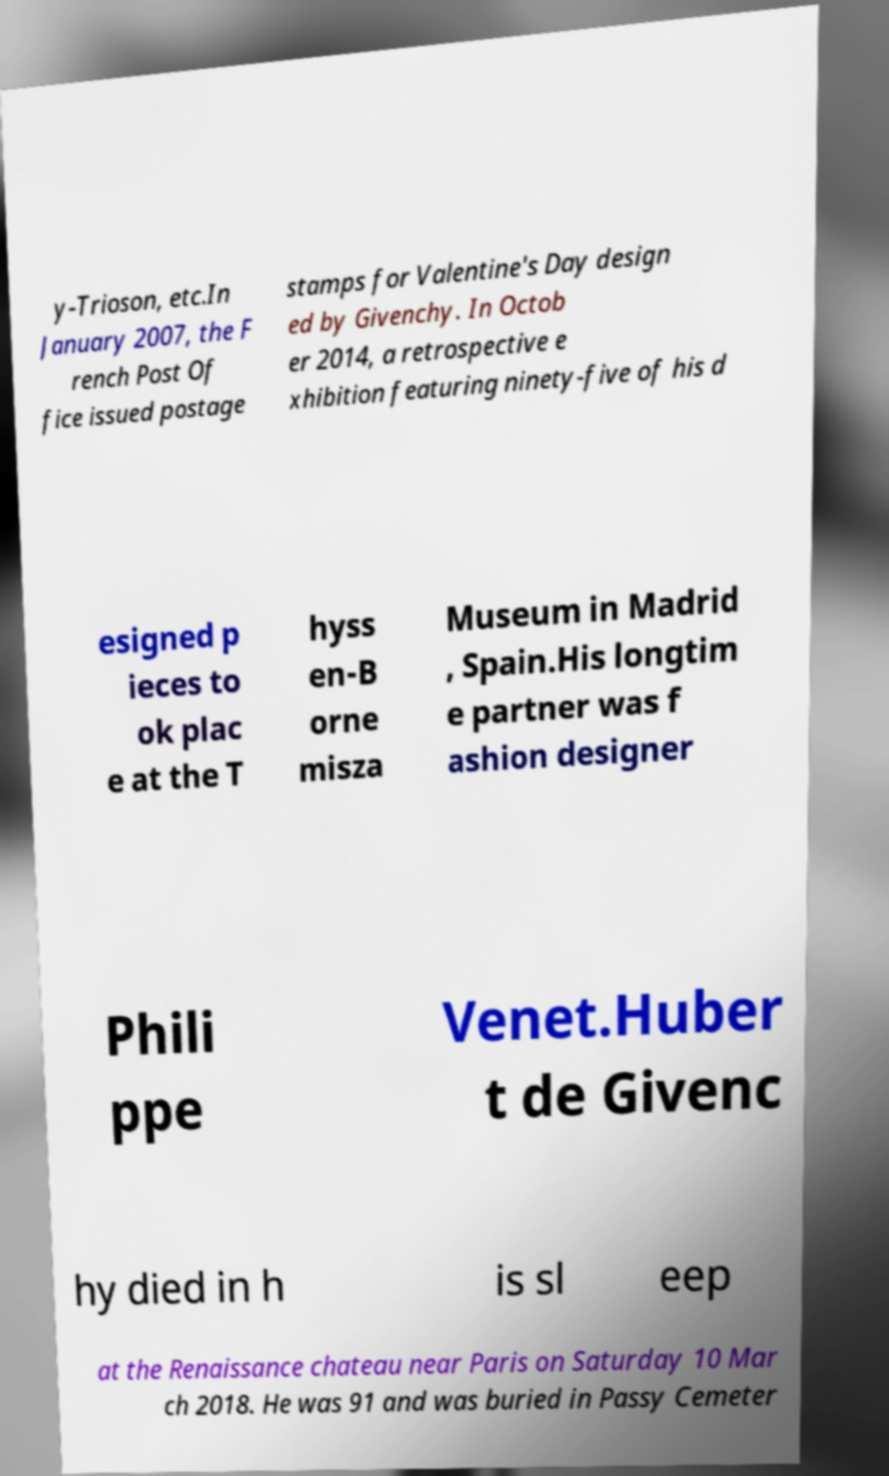Please identify and transcribe the text found in this image. y-Trioson, etc.In January 2007, the F rench Post Of fice issued postage stamps for Valentine's Day design ed by Givenchy. In Octob er 2014, a retrospective e xhibition featuring ninety-five of his d esigned p ieces to ok plac e at the T hyss en-B orne misza Museum in Madrid , Spain.His longtim e partner was f ashion designer Phili ppe Venet.Huber t de Givenc hy died in h is sl eep at the Renaissance chateau near Paris on Saturday 10 Mar ch 2018. He was 91 and was buried in Passy Cemeter 